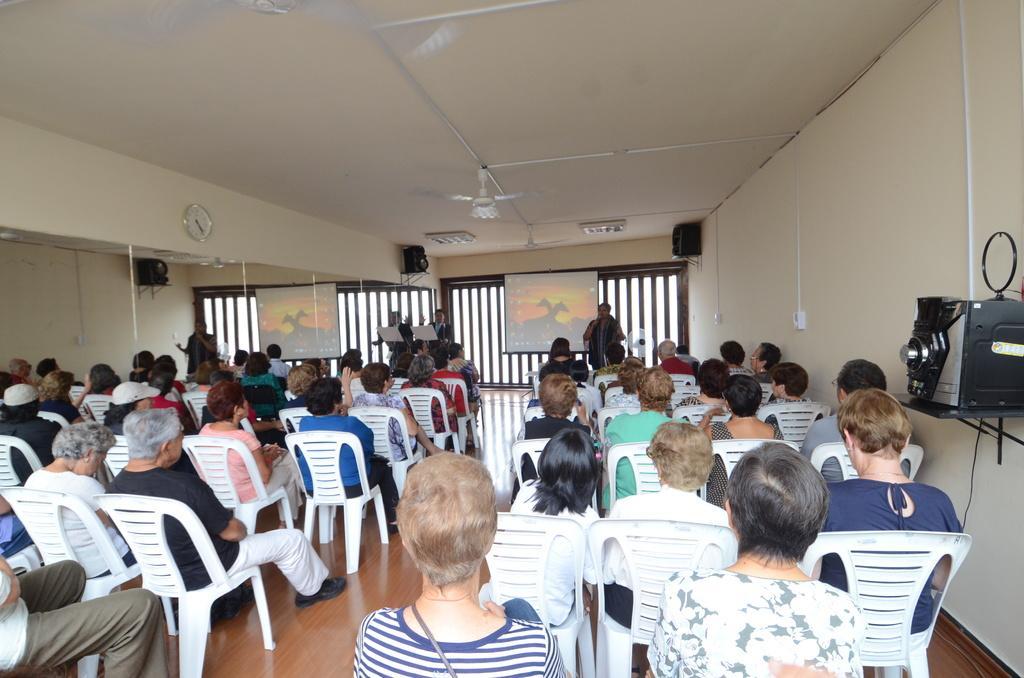Could you give a brief overview of what you see in this image? In this picture we can see a group of people sitting on chairs and in front of them we have three persons standing on stage and we have screen, wall, speakers, fan, clock. 